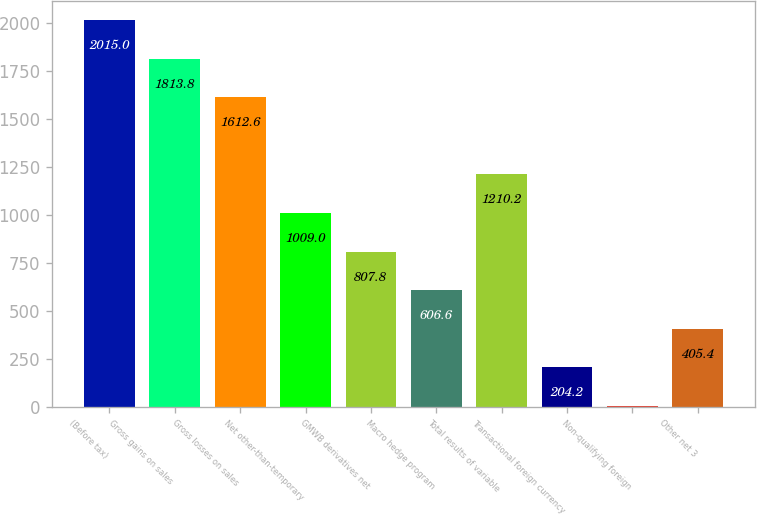<chart> <loc_0><loc_0><loc_500><loc_500><bar_chart><fcel>(Before tax)<fcel>Gross gains on sales<fcel>Gross losses on sales<fcel>Net other-than-temporary<fcel>GMWB derivatives net<fcel>Macro hedge program<fcel>Total results of variable<fcel>Transactional foreign currency<fcel>Non-qualifying foreign<fcel>Other net 3<nl><fcel>2015<fcel>1813.8<fcel>1612.6<fcel>1009<fcel>807.8<fcel>606.6<fcel>1210.2<fcel>204.2<fcel>3<fcel>405.4<nl></chart> 